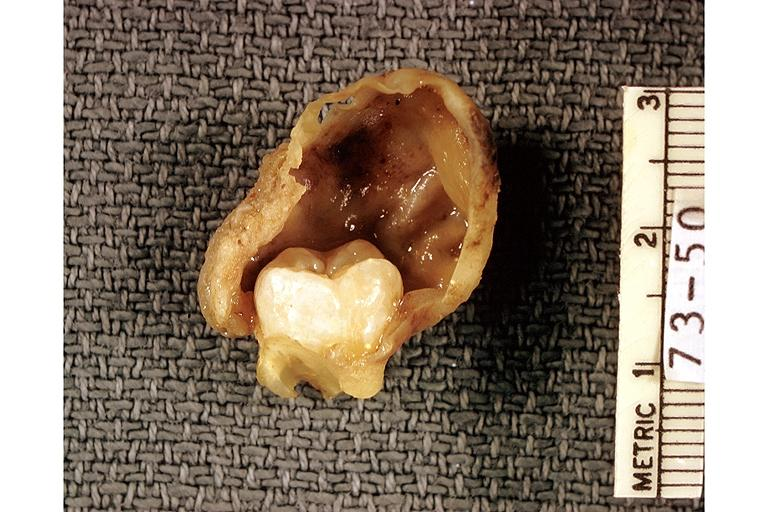what is present?
Answer the question using a single word or phrase. Oral 